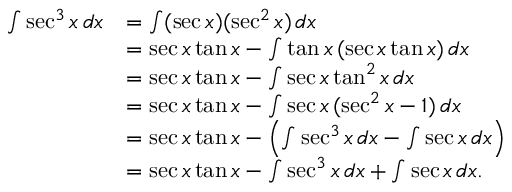Convert formula to latex. <formula><loc_0><loc_0><loc_500><loc_500>{ \begin{array} { r l } { \int \sec ^ { 3 } x \, d x } & { = \int ( \sec x ) ( \sec ^ { 2 } x ) \, d x } \\ & { = \sec x \tan x - \int \tan x \, ( \sec x \tan x ) \, d x } \\ & { = \sec x \tan x - \int \sec x \tan ^ { 2 } x \, d x } \\ & { = \sec x \tan x - \int \sec x \, ( \sec ^ { 2 } x - 1 ) \, d x } \\ & { = \sec x \tan x - \left ( \int \sec ^ { 3 } x \, d x - \int \sec x \, d x \right ) } \\ & { = \sec x \tan x - \int \sec ^ { 3 } x \, d x + \int \sec x \, d x . } \end{array} }</formula> 